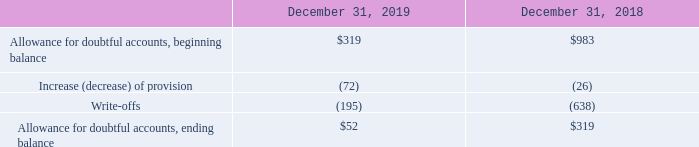6. Other Balance Sheet Account Details
Allowance for Doubtful Accounts
The following table presents the changes in the allowance for doubtful accounts (in thousands):
What data is covered by the table? Allowance for doubtful accounts. What is the allowance for doubtful accounts as at December 31, 2019?
Answer scale should be: thousand. $52. What is the allowance for doubtful accounts as at December 31, 2018?
Answer scale should be: thousand. $319. What is the total allowance for doubtful accounts, ending balance between 2018 and 2019?
Answer scale should be: thousand. 52+319
Answer: 371. What is the sum of the write-offs in 2018 and 2019?
Answer scale should be: thousand. 195 + 638 
Answer: 833. What is the percentage change in allowance for doubtful accounts, ending balance between 2018 and 2019?
Answer scale should be: percent. (52 - 319)/319 
Answer: -83.7. 